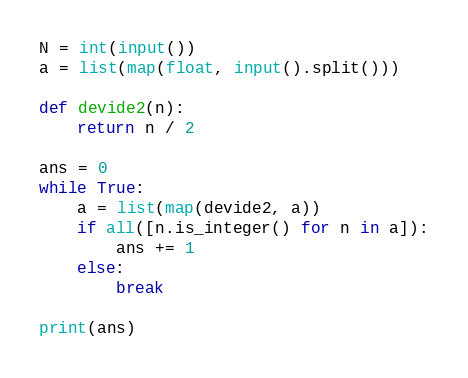Convert code to text. <code><loc_0><loc_0><loc_500><loc_500><_Python_>N = int(input())
a = list(map(float, input().split()))

def devide2(n):
    return n / 2

ans = 0
while True:
    a = list(map(devide2, a))
    if all([n.is_integer() for n in a]):
        ans += 1
    else:
        break

print(ans)</code> 